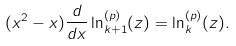<formula> <loc_0><loc_0><loc_500><loc_500>( x ^ { 2 } - x ) \frac { d } { d x } \ln _ { k + 1 } ^ { ( p ) } ( z ) = \ln _ { k } ^ { ( p ) } ( z ) .</formula> 